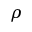Convert formula to latex. <formula><loc_0><loc_0><loc_500><loc_500>\rho</formula> 